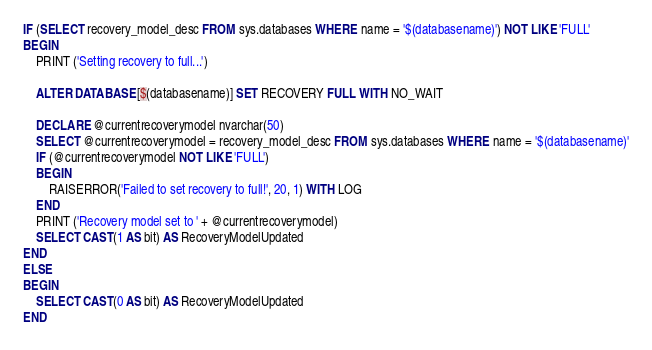Convert code to text. <code><loc_0><loc_0><loc_500><loc_500><_SQL_>IF (SELECT recovery_model_desc FROM sys.databases WHERE name = '$(databasename)') NOT LIKE 'FULL'
BEGIN
	PRINT ('Setting recovery to full...')

	ALTER DATABASE [$(databasename)] SET RECOVERY FULL WITH NO_WAIT

	DECLARE @currentrecoverymodel nvarchar(50)
	SELECT @currentrecoverymodel = recovery_model_desc FROM sys.databases WHERE name = '$(databasename)'
	IF (@currentrecoverymodel NOT LIKE 'FULL')
	BEGIN
		RAISERROR('Failed to set recovery to full!', 20, 1) WITH LOG
	END
	PRINT ('Recovery model set to ' + @currentrecoverymodel)
	SELECT CAST(1 AS bit) AS RecoveryModelUpdated
END
ELSE
BEGIN
	SELECT CAST(0 AS bit) AS RecoveryModelUpdated
END
</code> 